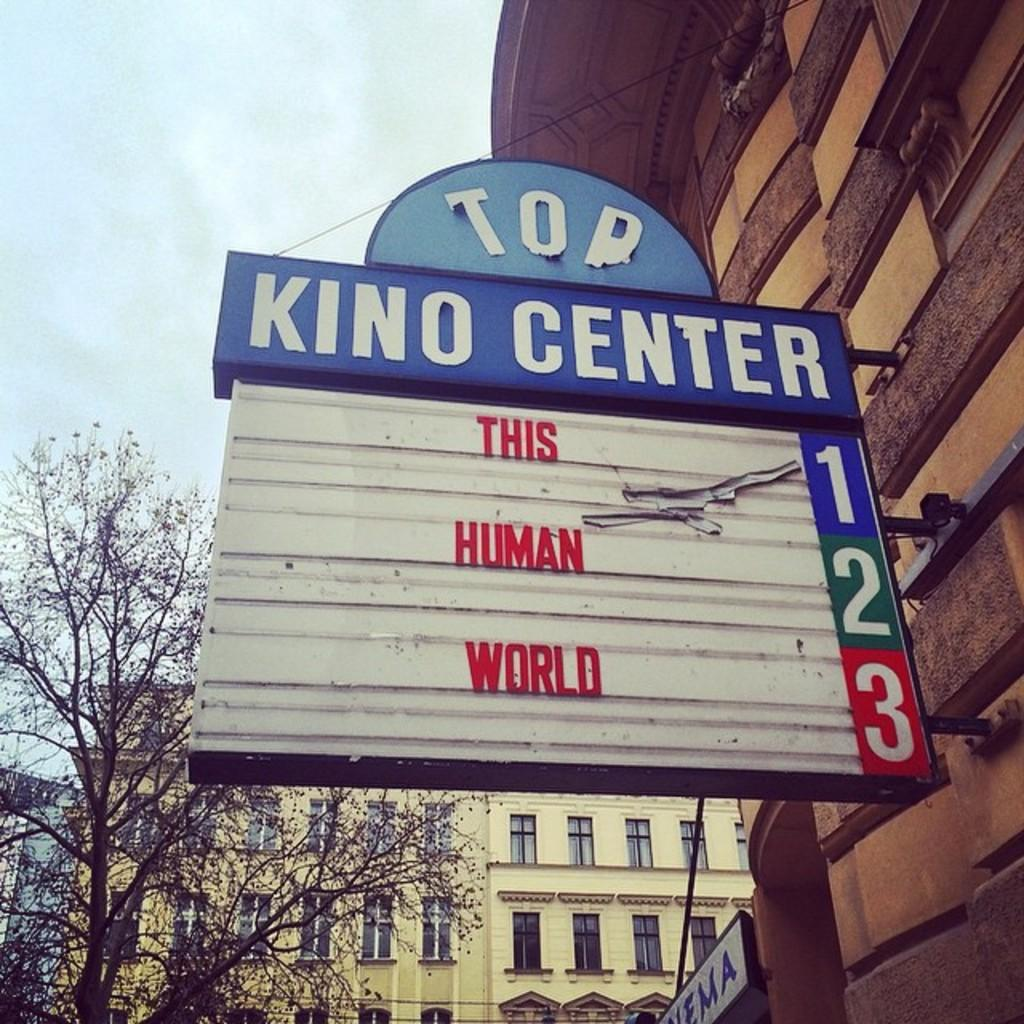What type of structures are present in the image? The image contains buildings. Can you describe a specific feature on one of the buildings? There is a board fixed to a wall in the image. What is written or displayed on the board? Text is visible on the board. What can be seen on the left side of the image? There is a tree on the left side of the image. What is visible at the top of the image? The sky is visible at the top of the image. Where is the family sitting on the stage in the image? There is no family sitting on a stage in the image; it does not contain a stage or any reference to a family. 